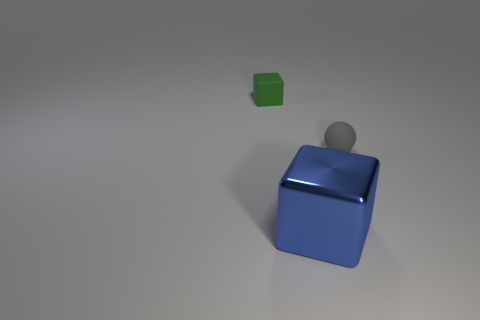Add 3 small green metallic cubes. How many objects exist? 6 Subtract all cubes. How many objects are left? 1 Subtract all yellow cubes. Subtract all blue spheres. How many cubes are left? 2 Subtract all brown blocks. How many green balls are left? 0 Subtract all small gray matte things. Subtract all small green things. How many objects are left? 1 Add 2 tiny balls. How many tiny balls are left? 3 Add 2 small red cubes. How many small red cubes exist? 2 Subtract 0 purple cylinders. How many objects are left? 3 Subtract 1 blocks. How many blocks are left? 1 